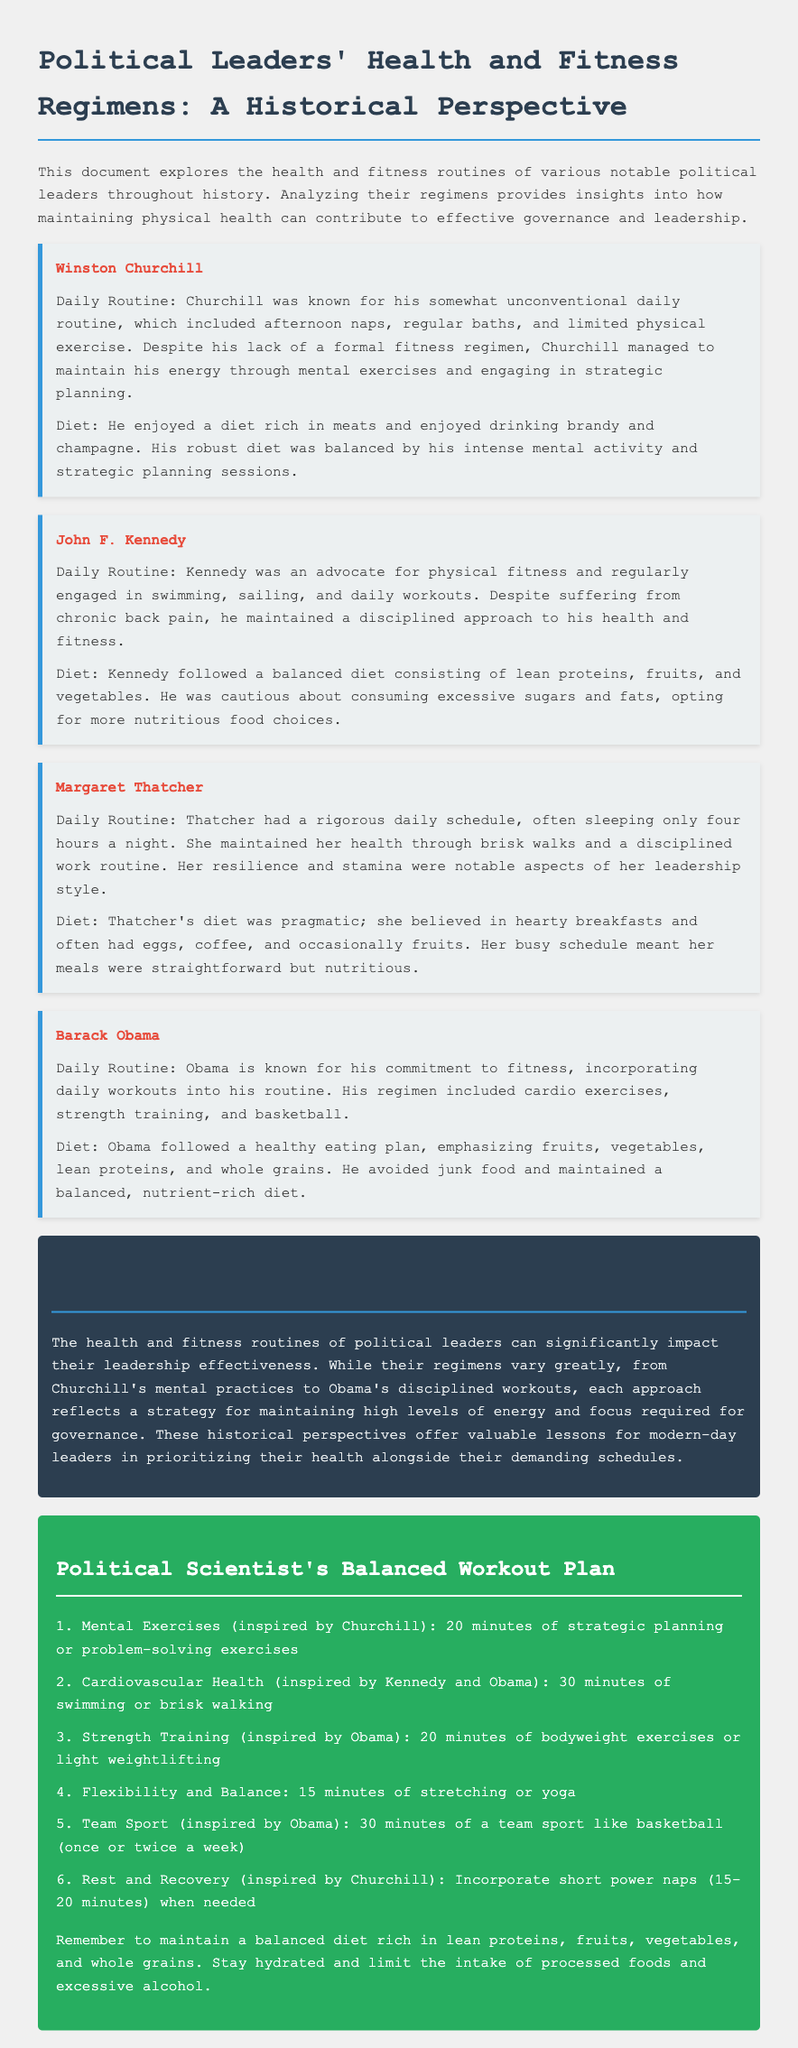What was Winston Churchill's daily routine? Churchill was known for his somewhat unconventional daily routine, which included afternoon naps, regular baths, and limited physical exercise.
Answer: Afternoon naps, regular baths What sport did Barack Obama incorporate into his fitness routine? Obama included basketball in his daily workouts as part of his commitment to fitness.
Answer: Basketball How many minutes of cardio exercises are recommended in the workout plan? The workout plan suggests 30 minutes of cardiovascular health activities, such as swimming or brisk walking.
Answer: 30 minutes What did Margaret Thatcher typically have for breakfast? Thatcher believed in hearty breakfasts and often had eggs, coffee, and occasionally fruits.
Answer: Eggs, coffee Which leader is noted for a regimented fitness routine despite chronic back pain? John F. Kennedy is recognized for maintaining a disciplined approach to health and fitness despite his chronic back pain.
Answer: John F. Kennedy What type of exercises are included in the strength training segment of the workout plan? The strength training section of the workout plan includes bodyweight exercises or light weightlifting.
Answer: Bodyweight exercises or light weightlifting What common dietary element did Barack Obama avoid? Obama avoided junk food as part of his healthy eating plan.
Answer: Junk food How long should the rest and recovery segment ideally last? The document suggests incorporating short power naps lasting 15-20 minutes for rest and recovery.
Answer: 15-20 minutes 